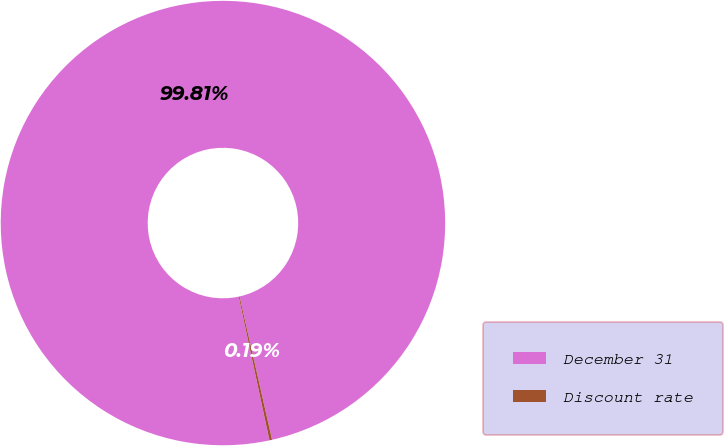Convert chart to OTSL. <chart><loc_0><loc_0><loc_500><loc_500><pie_chart><fcel>December 31<fcel>Discount rate<nl><fcel>99.81%<fcel>0.19%<nl></chart> 